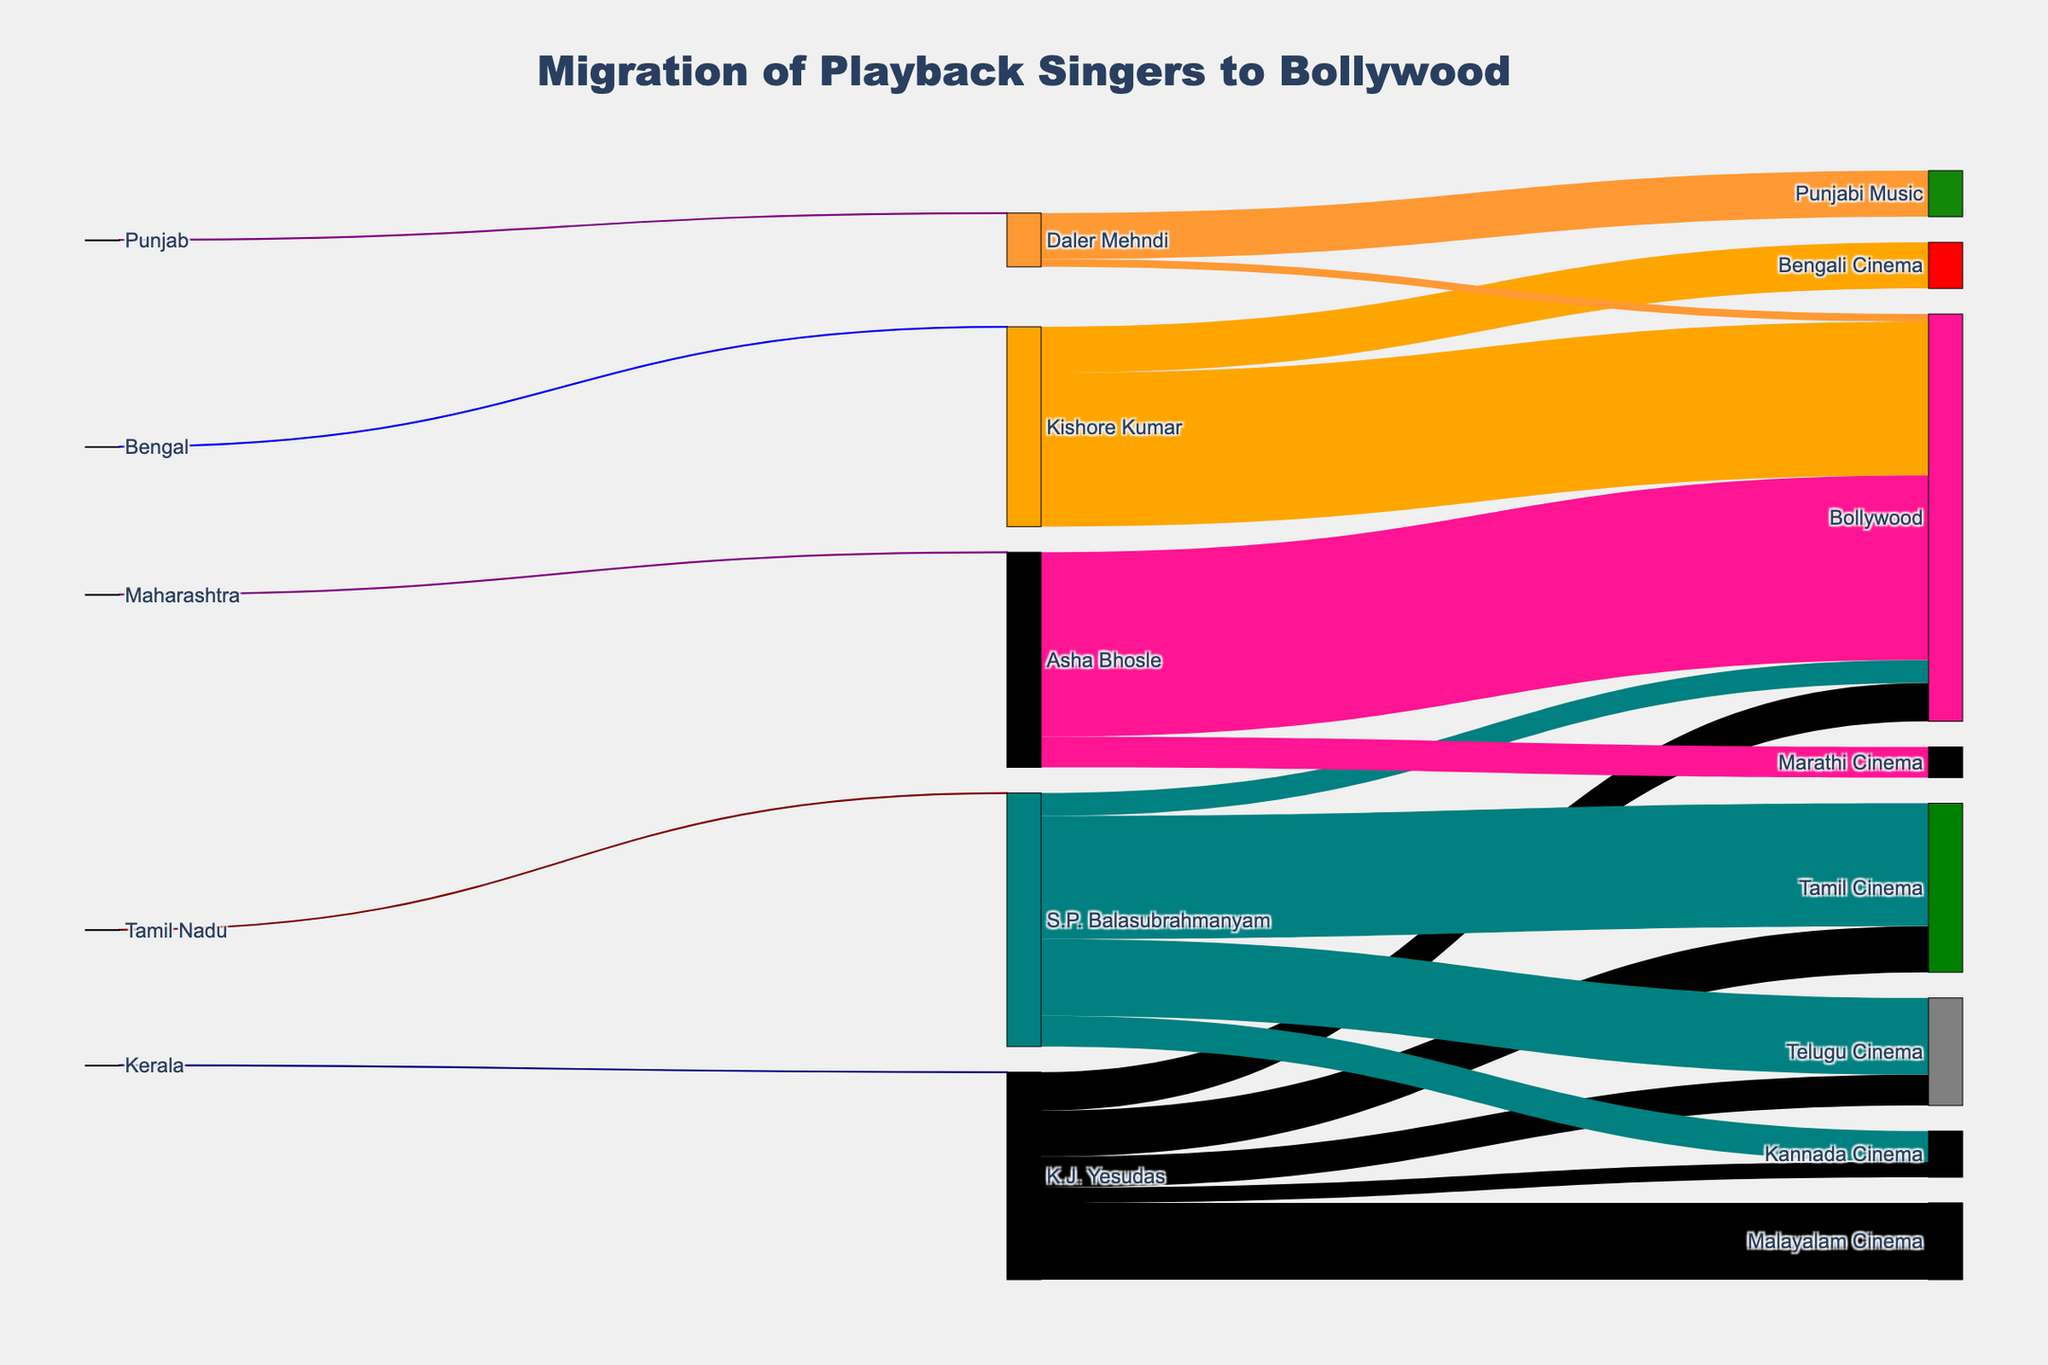How many playback singers from regional cinema have migrated to Bollywood according to the Sankey diagram? The Sankey diagram shows four playback singers migrating to Bollywood from different regional cinemas: K.J. Yesudas, S.P. Balasubrahmanyam, Kishore Kumar, and Asha Bhosle.
Answer: 4 What is the total number of songs that K.J. Yesudas has contributed to different cinema industries? Sum the values of all links connecting K.J. Yesudas to different cinema industries: Malayalam Cinema (500) + Tamil Cinema (300) + Telugu Cinema (200) + Kannada Cinema (100) + Bollywood (250). The total is 500 + 300 + 200 + 100 + 250.
Answer: 1350 Compare the number of songs K.J. Yesudas sang in Bollywood to those S.P. Balasubrahmanyam sang in Bollywood. Who contributed more songs? K.J. Yesudas sang 250 songs in Bollywood, while S.P. Balasubrahmanyam sang 150 songs in Bollywood. By comparing these numbers, K.J. Yesudas contributed more songs.
Answer: K.J. Yesudas Which singer has the highest number of songs in Bollywood as per the diagram? Look at the Bollywood connections in the diagram and compare the number of songs each singer contributed: K.J. Yesudas (250), S.P. Balasubrahmanyam (150), Kishore Kumar (1000), Asha Bhosle (1200), and Daler Mehndi (50). Asha Bhosle has the highest number of songs.
Answer: Asha Bhosle How many more songs did Kishore Kumar sing in Bollywood compared to K.J. Yesudas? Kishore Kumar sang 1000 songs in Bollywood while K.J. Yesudas sang 250. The difference is calculated as 1000 - 250.
Answer: 750 Which cinema industry did K.J. Yesudas contribute to the least, and how many songs did he sing in that industry? Look at the connections from K.J. Yesudas to various cinema industries and find the smallest value: Kannada Cinema (100) is the least, followed by Telugu Cinema (200), Tamil Cinema (300), and Malayalam Cinema (500).
Answer: Kannada Cinema, 100 What is the combined total of songs contributed by S.P. Balasubrahmanyam in all cinema industries depicted? Sum the values of all links connecting S.P. Balasubrahmanyam to different cinema industries: Tamil Cinema (800) + Telugu Cinema (500) + Kannada Cinema (200) + Bollywood (150). The total is 800 + 500 + 200 + 150.
Answer: 1650 Which regional cinema did K.J. Yesudas come from, and how many singers from that region are depicted in the Sankey diagram? K.J. Yesudas came from Kerala. According to the diagram, there is only one singer from Kerala depicted (K.J. Yesudas).
Answer: Kerala, 1 Order the singers based on their total contributions to Bollywood. Compare the Bollywood contributions for each singer: Asha Bhosle (1200), Kishore Kumar (1000), K.J. Yesudas (250), S.P. Balasubrahmanyam (150), Daler Mehndi (50). Ordering them gives: Asha Bhosle, Kishore Kumar, K.J. Yesudas, S.P. Balasubrahmanyam, Daler Mehndi.
Answer: Asha Bhosle, Kishore Kumar, K.J. Yesudas, S.P. Balasubrahmanyam, Daler Mehndi 